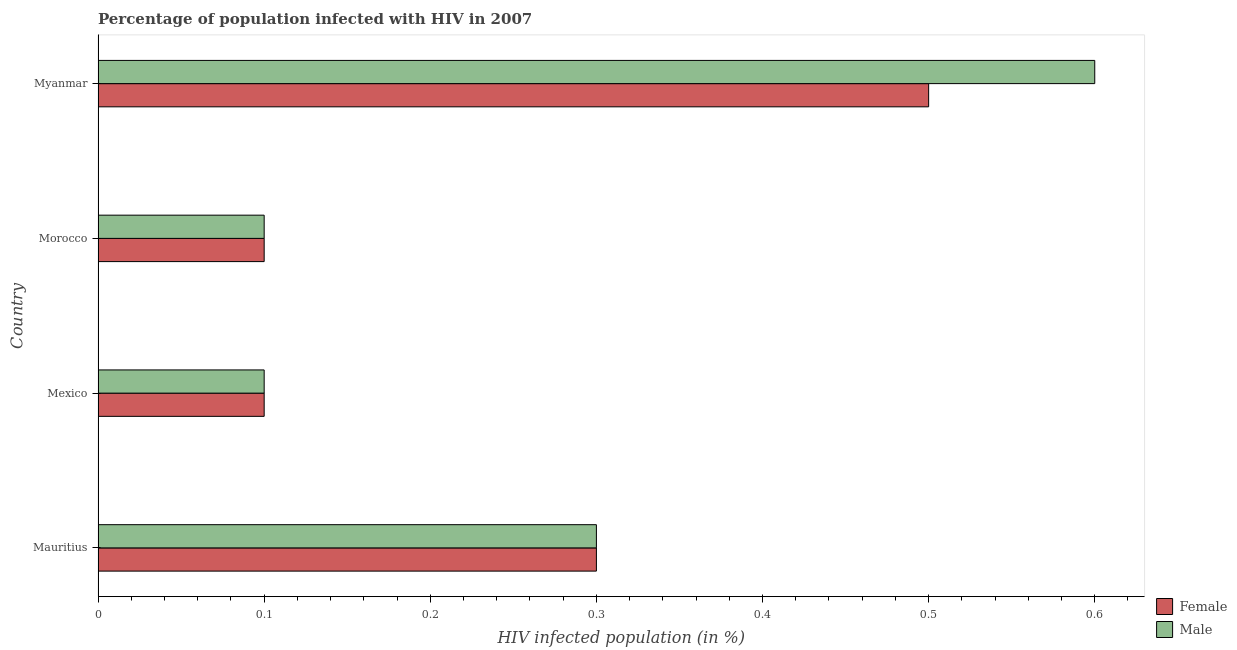Are the number of bars on each tick of the Y-axis equal?
Your answer should be compact. Yes. What is the label of the 1st group of bars from the top?
Give a very brief answer. Myanmar. In how many cases, is the number of bars for a given country not equal to the number of legend labels?
Your response must be concise. 0. Across all countries, what is the minimum percentage of females who are infected with hiv?
Provide a short and direct response. 0.1. In which country was the percentage of females who are infected with hiv maximum?
Offer a very short reply. Myanmar. What is the total percentage of males who are infected with hiv in the graph?
Ensure brevity in your answer.  1.1. What is the difference between the percentage of females who are infected with hiv in Morocco and that in Myanmar?
Offer a terse response. -0.4. What is the difference between the percentage of females who are infected with hiv in Mexico and the percentage of males who are infected with hiv in Mauritius?
Your answer should be compact. -0.2. What is the average percentage of males who are infected with hiv per country?
Offer a very short reply. 0.28. What is the difference between the percentage of females who are infected with hiv and percentage of males who are infected with hiv in Mauritius?
Offer a terse response. 0. Is the difference between the percentage of females who are infected with hiv in Mauritius and Myanmar greater than the difference between the percentage of males who are infected with hiv in Mauritius and Myanmar?
Offer a very short reply. Yes. How many bars are there?
Your answer should be compact. 8. Are all the bars in the graph horizontal?
Keep it short and to the point. Yes. Does the graph contain any zero values?
Your answer should be compact. No. How many legend labels are there?
Your answer should be very brief. 2. What is the title of the graph?
Give a very brief answer. Percentage of population infected with HIV in 2007. Does "Official aid received" appear as one of the legend labels in the graph?
Keep it short and to the point. No. What is the label or title of the X-axis?
Your response must be concise. HIV infected population (in %). What is the label or title of the Y-axis?
Offer a terse response. Country. What is the HIV infected population (in %) in Female in Morocco?
Keep it short and to the point. 0.1. What is the HIV infected population (in %) of Male in Morocco?
Provide a succinct answer. 0.1. What is the HIV infected population (in %) of Female in Myanmar?
Ensure brevity in your answer.  0.5. Across all countries, what is the maximum HIV infected population (in %) of Female?
Make the answer very short. 0.5. Across all countries, what is the maximum HIV infected population (in %) in Male?
Offer a very short reply. 0.6. What is the total HIV infected population (in %) of Female in the graph?
Your answer should be very brief. 1. What is the difference between the HIV infected population (in %) of Male in Mauritius and that in Mexico?
Your answer should be compact. 0.2. What is the difference between the HIV infected population (in %) in Female in Mauritius and that in Morocco?
Provide a succinct answer. 0.2. What is the difference between the HIV infected population (in %) in Female in Mexico and that in Morocco?
Make the answer very short. 0. What is the difference between the HIV infected population (in %) of Male in Mexico and that in Morocco?
Give a very brief answer. 0. What is the difference between the HIV infected population (in %) in Male in Morocco and that in Myanmar?
Make the answer very short. -0.5. What is the difference between the HIV infected population (in %) in Female in Mauritius and the HIV infected population (in %) in Male in Myanmar?
Your response must be concise. -0.3. What is the difference between the HIV infected population (in %) of Female in Morocco and the HIV infected population (in %) of Male in Myanmar?
Your answer should be compact. -0.5. What is the average HIV infected population (in %) in Female per country?
Offer a terse response. 0.25. What is the average HIV infected population (in %) of Male per country?
Provide a succinct answer. 0.28. What is the difference between the HIV infected population (in %) in Female and HIV infected population (in %) in Male in Myanmar?
Provide a succinct answer. -0.1. What is the ratio of the HIV infected population (in %) in Female in Mauritius to that in Mexico?
Make the answer very short. 3. What is the ratio of the HIV infected population (in %) in Female in Mauritius to that in Morocco?
Your answer should be very brief. 3. What is the ratio of the HIV infected population (in %) in Male in Mauritius to that in Myanmar?
Ensure brevity in your answer.  0.5. What is the ratio of the HIV infected population (in %) in Male in Mexico to that in Morocco?
Offer a very short reply. 1. What is the ratio of the HIV infected population (in %) in Male in Morocco to that in Myanmar?
Your answer should be very brief. 0.17. What is the difference between the highest and the second highest HIV infected population (in %) in Female?
Your answer should be very brief. 0.2. What is the difference between the highest and the lowest HIV infected population (in %) in Female?
Ensure brevity in your answer.  0.4. 